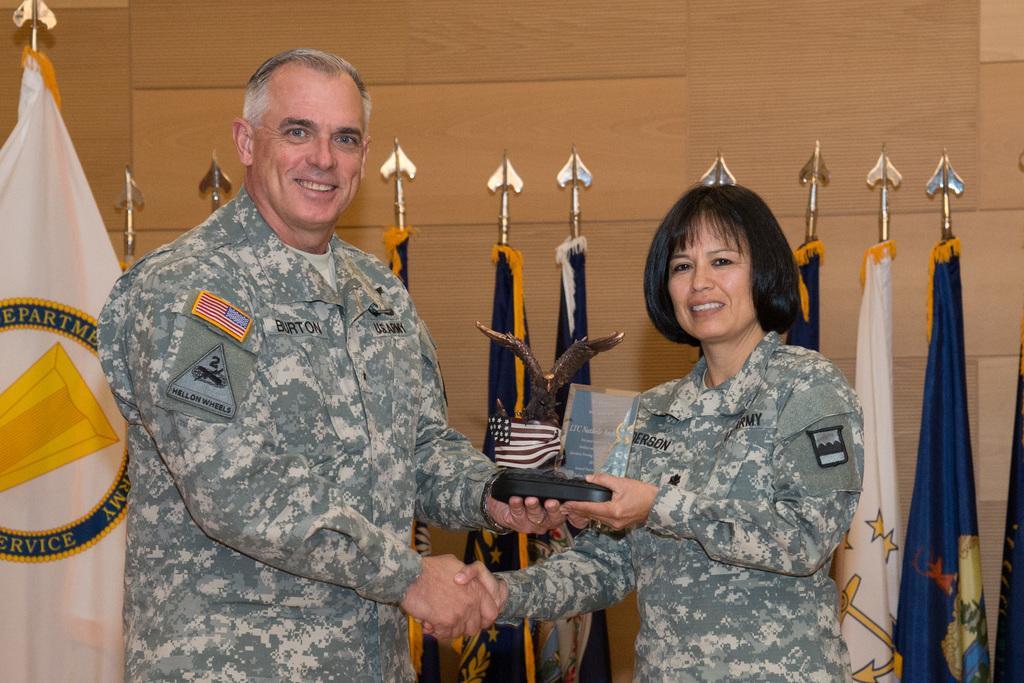Could you give a brief overview of what you see in this image? In this picture there is a soldier on the left side of the image and there is a lady on the right side of the image, by holding a trophy in their hands and there are flags in the background area of the image. 